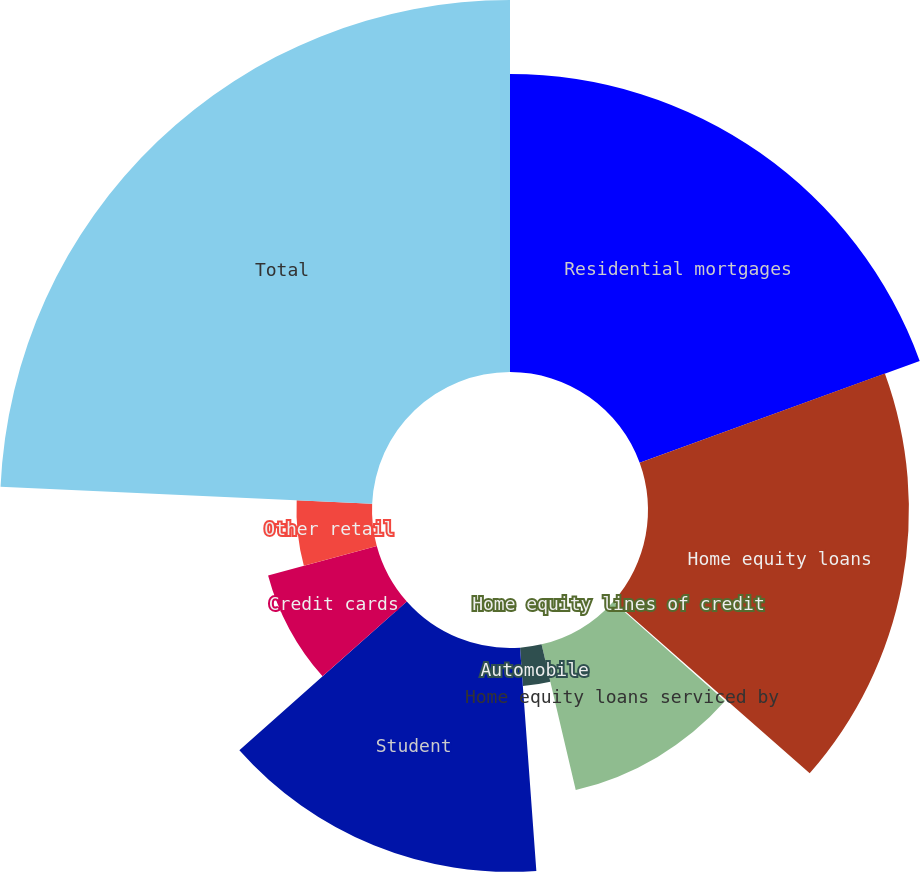Convert chart. <chart><loc_0><loc_0><loc_500><loc_500><pie_chart><fcel>Residential mortgages<fcel>Home equity loans<fcel>Home equity lines of credit<fcel>Home equity loans serviced by<fcel>Automobile<fcel>Student<fcel>Credit cards<fcel>Other retail<fcel>Total<nl><fcel>19.45%<fcel>17.03%<fcel>0.09%<fcel>9.77%<fcel>2.51%<fcel>14.61%<fcel>7.35%<fcel>4.93%<fcel>24.28%<nl></chart> 